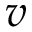<formula> <loc_0><loc_0><loc_500><loc_500>v</formula> 